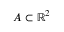<formula> <loc_0><loc_0><loc_500><loc_500>A \subset \mathbb { R } ^ { 2 }</formula> 